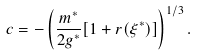<formula> <loc_0><loc_0><loc_500><loc_500>c = - \left ( \frac { m ^ { * } } { 2 g ^ { * } } [ 1 + r ( \xi ^ { * } ) ] \right ) ^ { 1 / 3 } .</formula> 